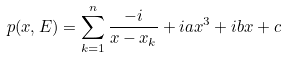Convert formula to latex. <formula><loc_0><loc_0><loc_500><loc_500>p ( x , E ) = \sum _ { k = 1 } ^ { n } \frac { - i } { x - x _ { k } } + i a x ^ { 3 } + i b x + c</formula> 